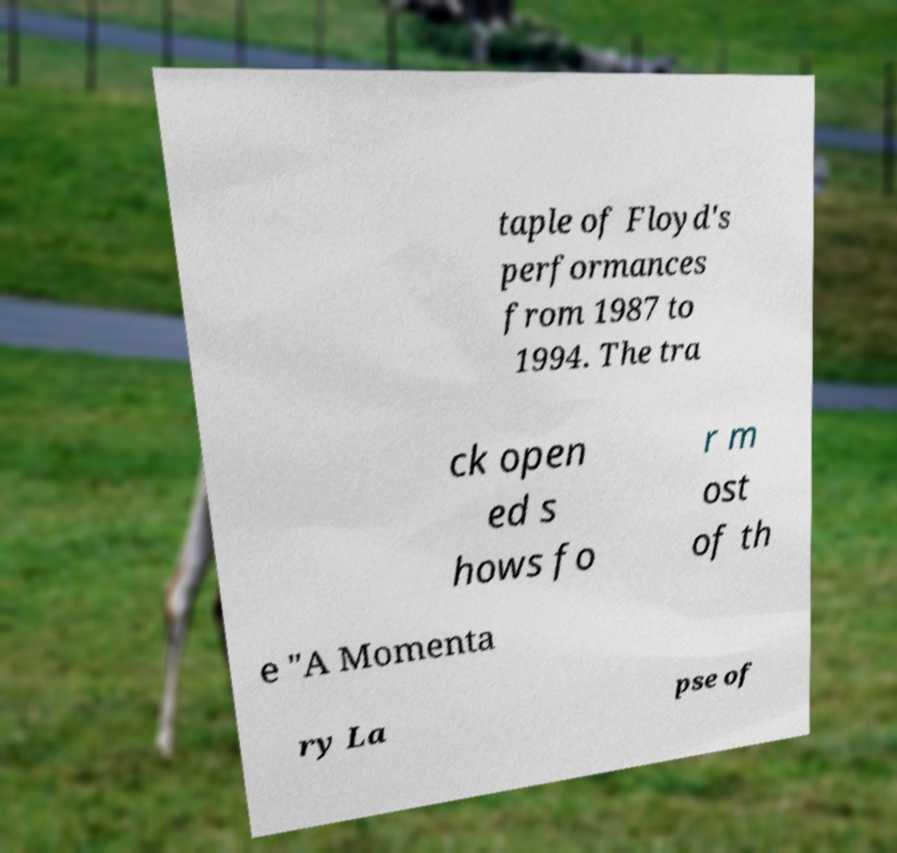Could you extract and type out the text from this image? taple of Floyd's performances from 1987 to 1994. The tra ck open ed s hows fo r m ost of th e "A Momenta ry La pse of 